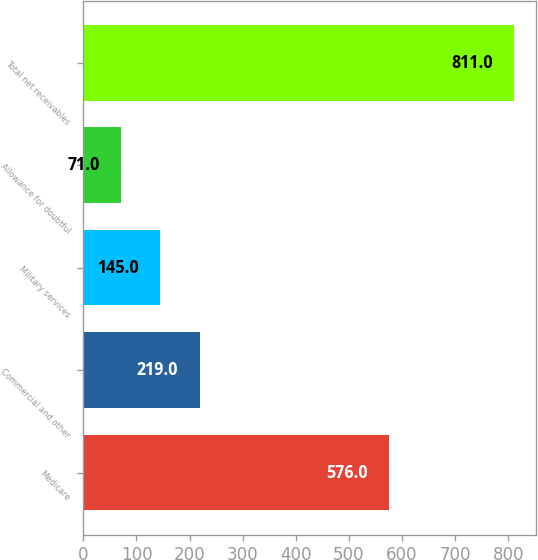<chart> <loc_0><loc_0><loc_500><loc_500><bar_chart><fcel>Medicare<fcel>Commercial and other<fcel>Military services<fcel>Allowance for doubtful<fcel>Total net receivables<nl><fcel>576<fcel>219<fcel>145<fcel>71<fcel>811<nl></chart> 